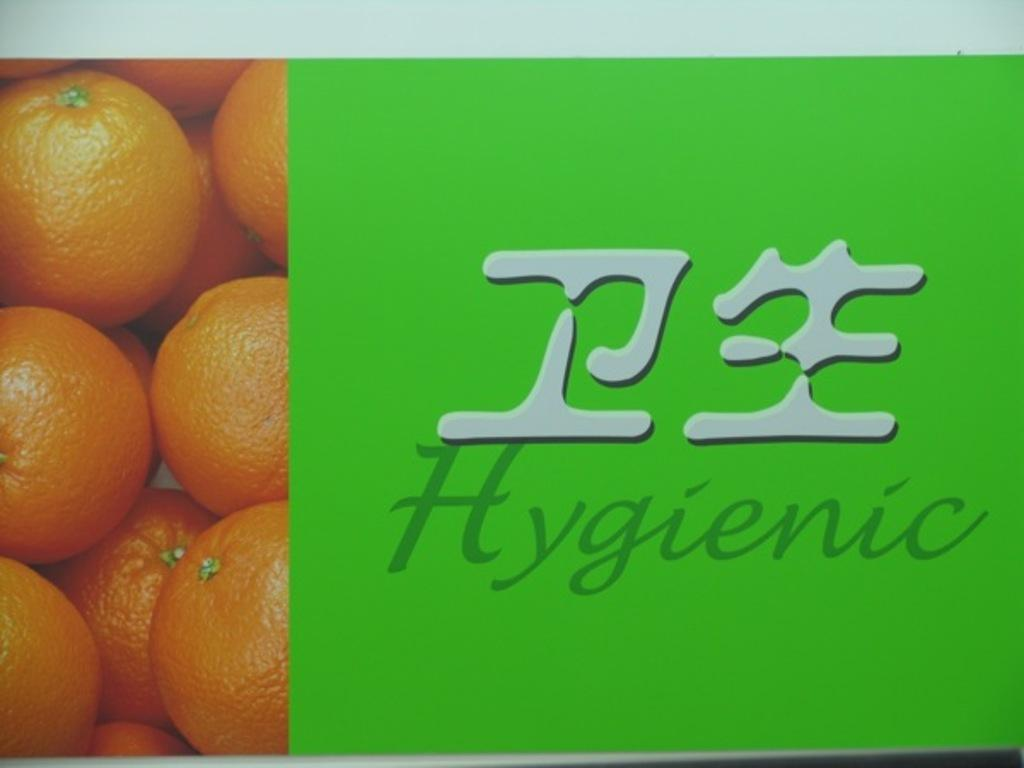What is depicted in the photo in the image? There is a photo of oranges in the image. What else can be seen in the image besides the photo of oranges? There are two words written on a paper in the image. What type of cork can be seen in the image? There is no cork present in the image. What is being served for dinner in the image? The image does not depict a dinner scene, so it cannot be determined what is being served. 